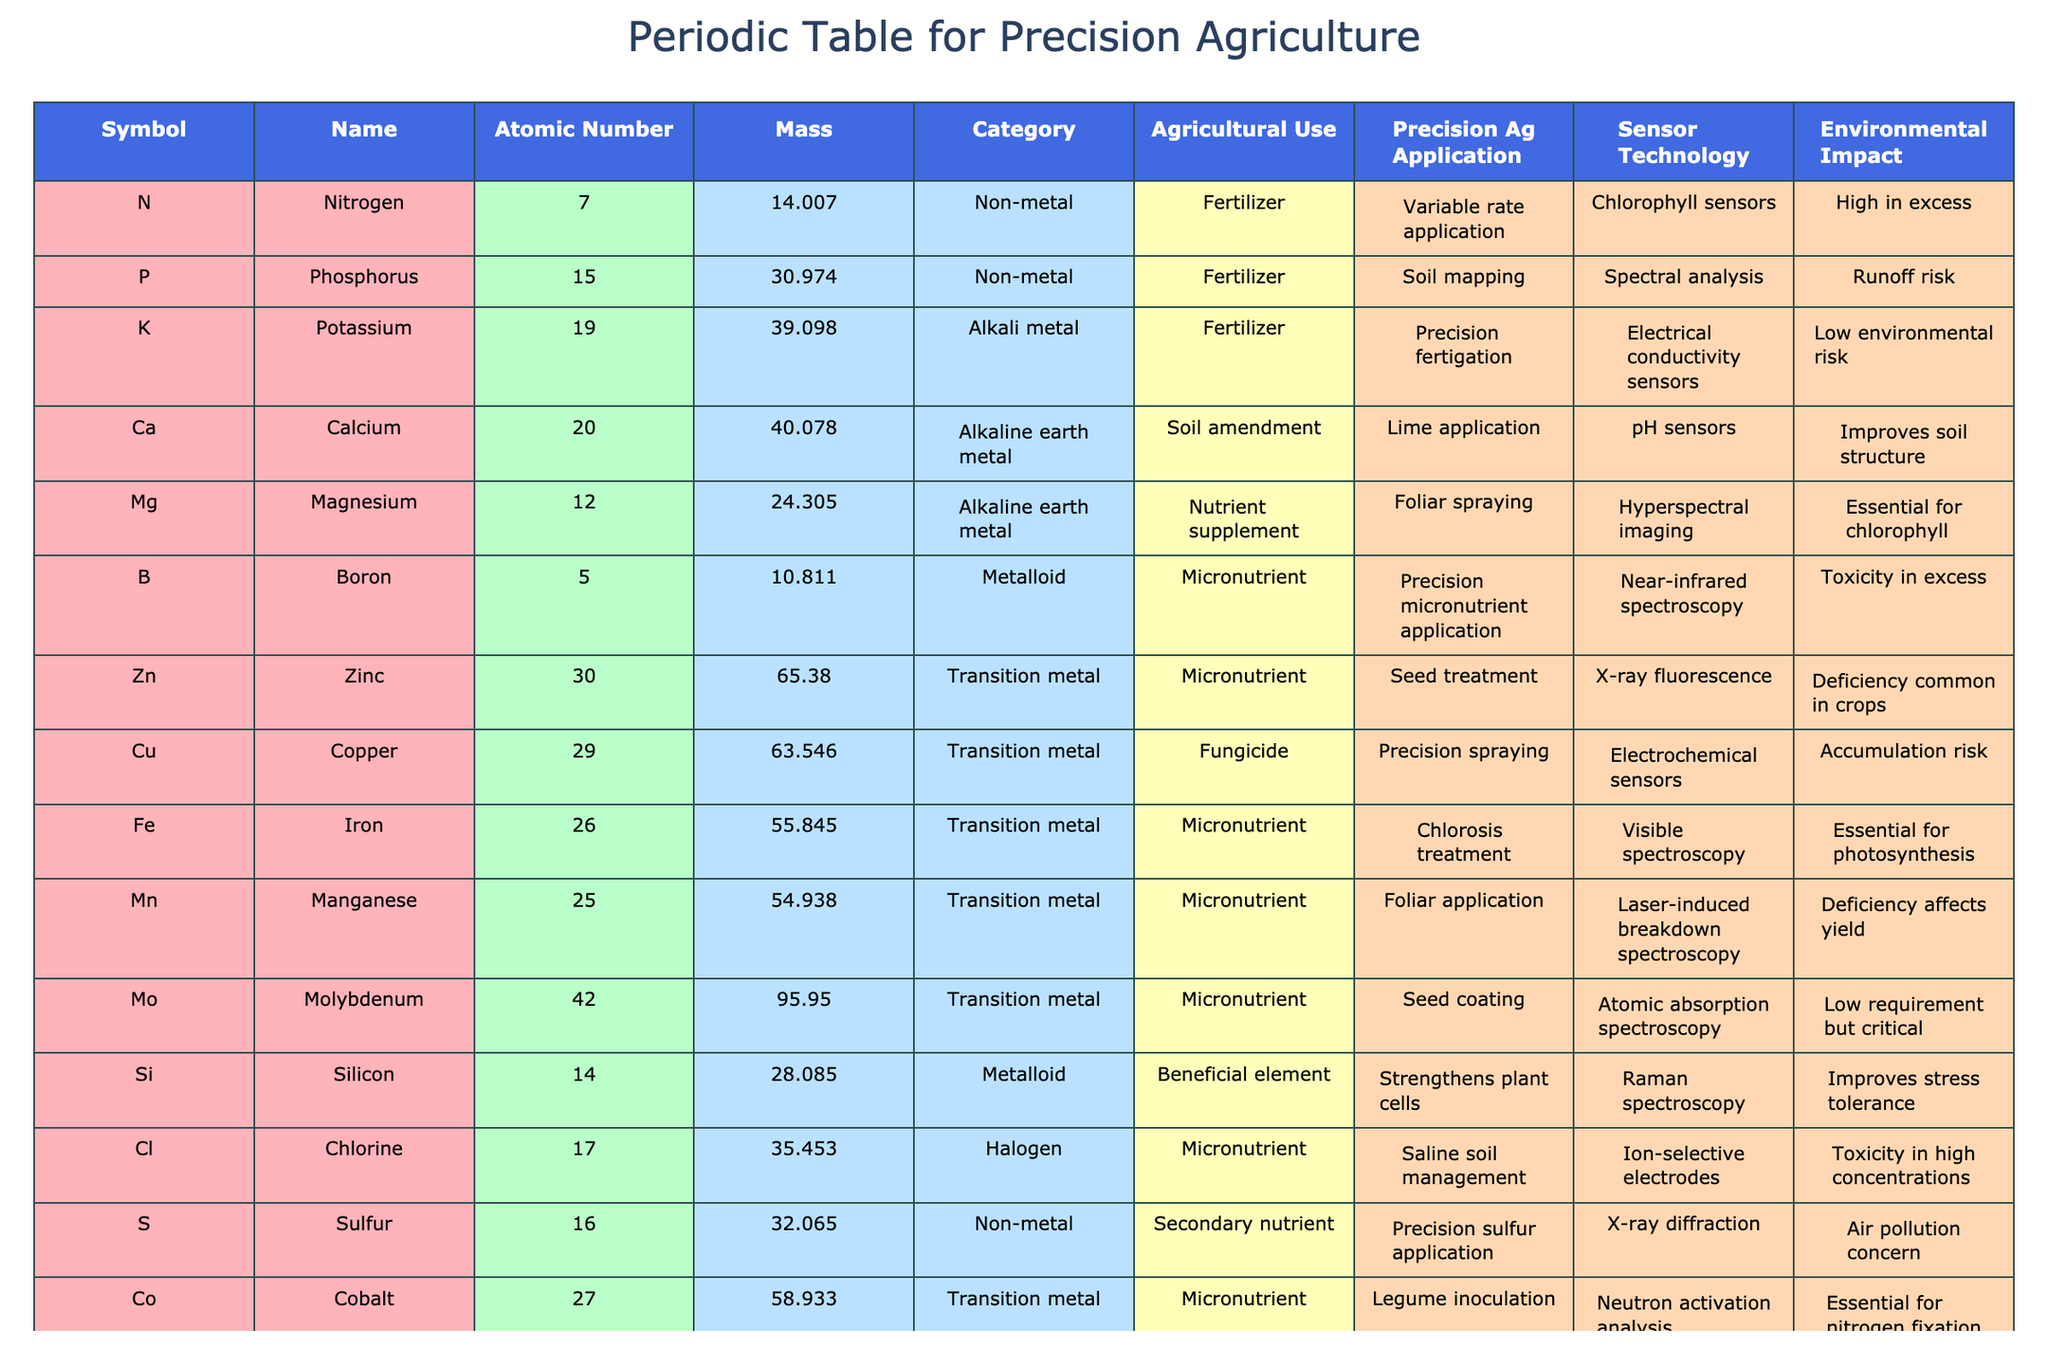What is the atomic number of nitrogen? The table lists nitrogen under the Symbol column as "N". According to the corresponding row, the Atomic Number for nitrogen is 7.
Answer: 7 Which element has the highest environmental impact in excess? By reviewing the Environmental Impact column, "High in excess" is mentioned under nitrogen and "Toxicity in excess" is noted for boron and chlorine. Since nitrogen is the only one with a specified "high" impact, it can be determined that nitrogen has the highest environmental impact in excess.
Answer: Nitrogen What is the mass of potassium? The table lists potassium as "K" in the Symbol column, and under the Mass column, the value for potassium is 39.098.
Answer: 39.098 How many micronutrients are listed in the table? From the table, the elements that fall under the category of micronutrients are boron, zinc, iron, manganese, molybdenum, cobalt, and chlorine. Counting these gives a total of 7 micronutrients.
Answer: 7 Is potassium classified as a transition metal? The Category for potassium is clearly listed as "Alkali metal" in the table, so it is not a transition metal.
Answer: No Which element has the lowest atomic number among micronutrients? The atomic numbers for the micronutrients listed are boron (5), zinc (30), iron (26), manganese (25), molybdenum (42), cobalt (27), and chlorine (17). Among these, the lowest atomic number is 5 for boron.
Answer: Boron What is the average atomic mass of the alkaline earth metals listed? The alkaline earth metals in the table are calcium (40.078) and magnesium (24.305). To find the average, we sum these values: 40.078 + 24.305 = 64.383. Then, we divide by 2, so the average is 64.383 / 2 = 32.1915.
Answer: 32.1915 Identify the element with the application for 'precision spraying'. Looking at the Precision Ag Application column, the only element listed with 'precision spraying' is copper. By checking the corresponding row, we find that copper is represented by the symbol "Cu".
Answer: Copper How many elements are categorized as non-metals? The non-metals listed in the table are nitrogen, phosphorus, potassium, sulfur, and calcium. Counting these, we get a total of 4 elements categorized as non-metals in the list.
Answer: 4 What is the environmental impact of silicon? The Environmental Impact column for silicon indicates "Improves stress tolerance", meaning that it does not pose a risk like other elements indicating toxicity or high impact.
Answer: Improves stress tolerance 